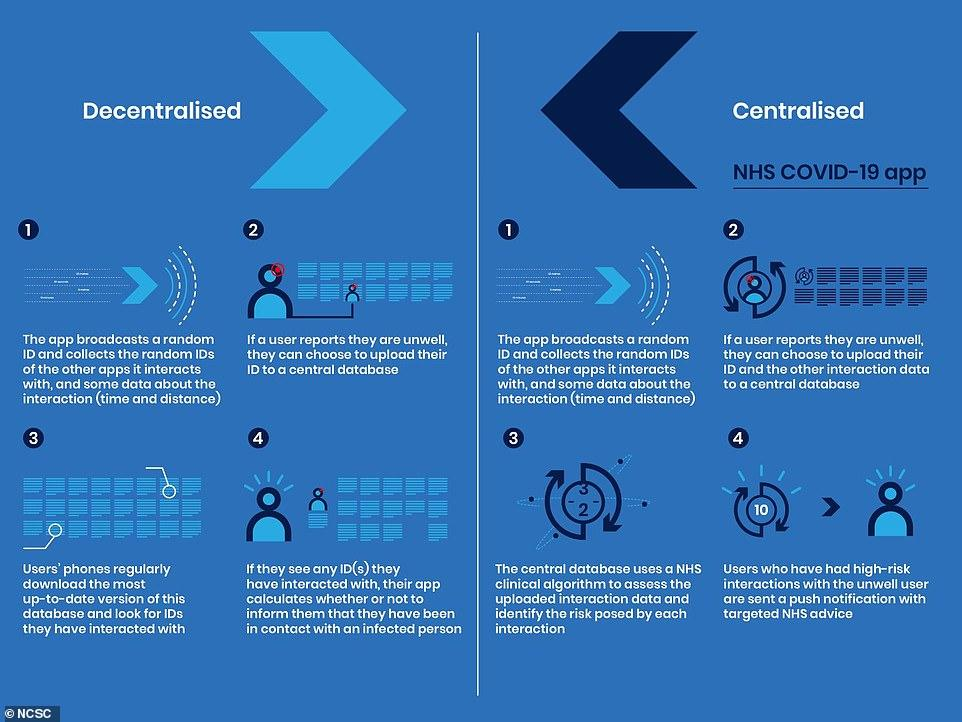Mention a couple of crucial points in this snapshot. Decentralized systems allow users to upload their personal identification to a central database upon reporting their illness. The second step in a centralized approach is for a user to report their illness and choose to provide their identity and other interaction data to a central database if desired. The number of steps in the app processing for decentralized systems is given as 4. The number of steps in app processing is provided in the centralized section, and it is 4. There is a commonality of 1 step between centralized and decentralized systems in that both involve a progression from 1 to... 